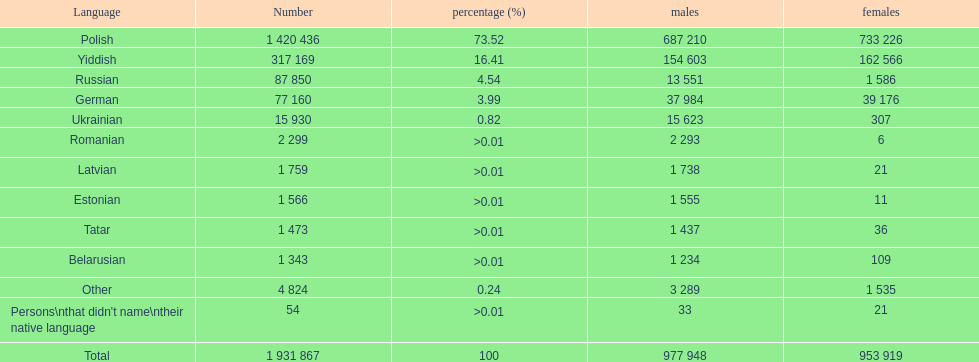Which language had the smallest number of females speaking it. Romanian. 